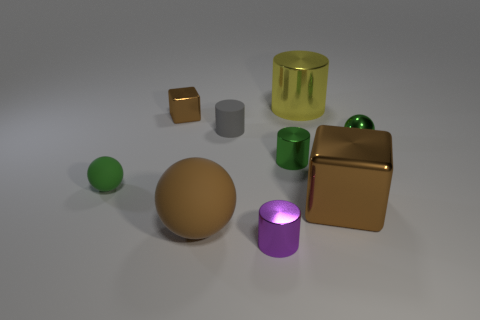What size is the cylinder that is the same color as the metallic ball?
Your response must be concise. Small. Is there a large purple cube made of the same material as the tiny brown cube?
Provide a succinct answer. No. Are there an equal number of tiny green metallic balls in front of the big metallic cube and blocks on the left side of the large metallic cylinder?
Your response must be concise. No. What is the size of the brown cube that is to the left of the large yellow object?
Your answer should be compact. Small. What is the material of the brown cube behind the tiny green sphere that is on the left side of the big yellow object?
Ensure brevity in your answer.  Metal. There is a green cylinder in front of the brown metallic cube to the left of the big brown metal block; what number of small green things are on the left side of it?
Offer a very short reply. 1. Does the sphere on the left side of the brown rubber ball have the same material as the big brown object that is to the right of the yellow metallic cylinder?
Provide a short and direct response. No. What material is the small thing that is the same color as the big metallic cube?
Provide a short and direct response. Metal. What number of brown rubber objects are the same shape as the small gray rubber object?
Offer a terse response. 0. Are there more brown spheres that are in front of the tiny purple metallic cylinder than small cylinders?
Offer a terse response. No. 